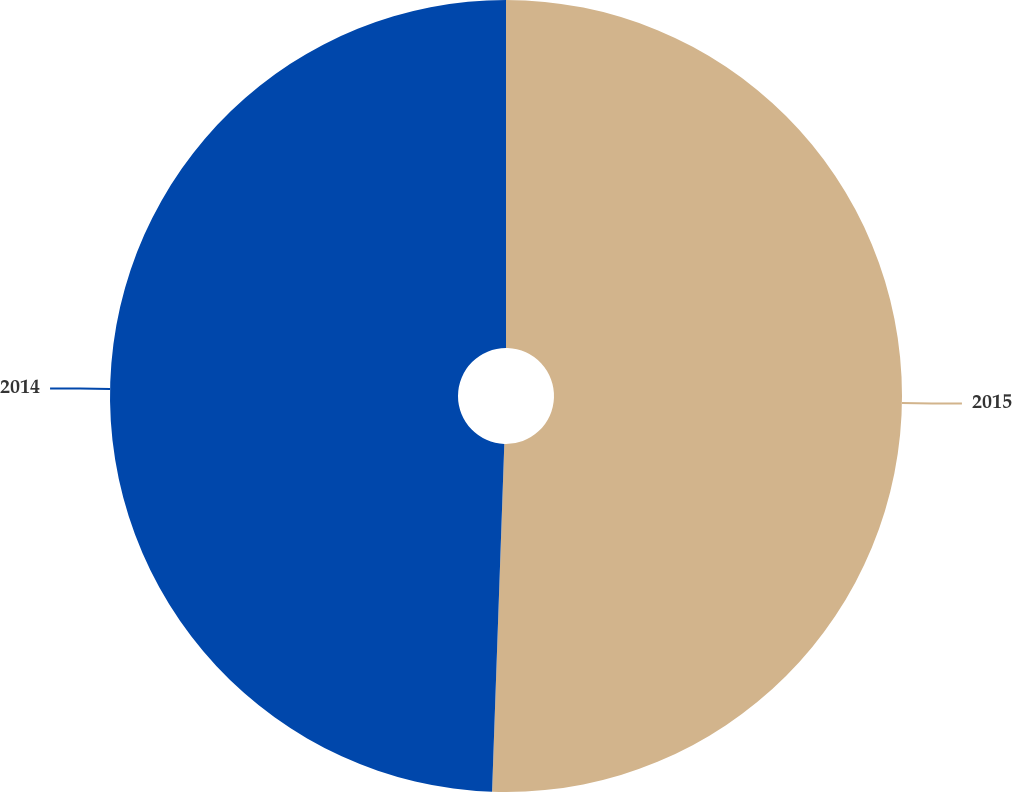Convert chart to OTSL. <chart><loc_0><loc_0><loc_500><loc_500><pie_chart><fcel>2015<fcel>2014<nl><fcel>50.56%<fcel>49.44%<nl></chart> 